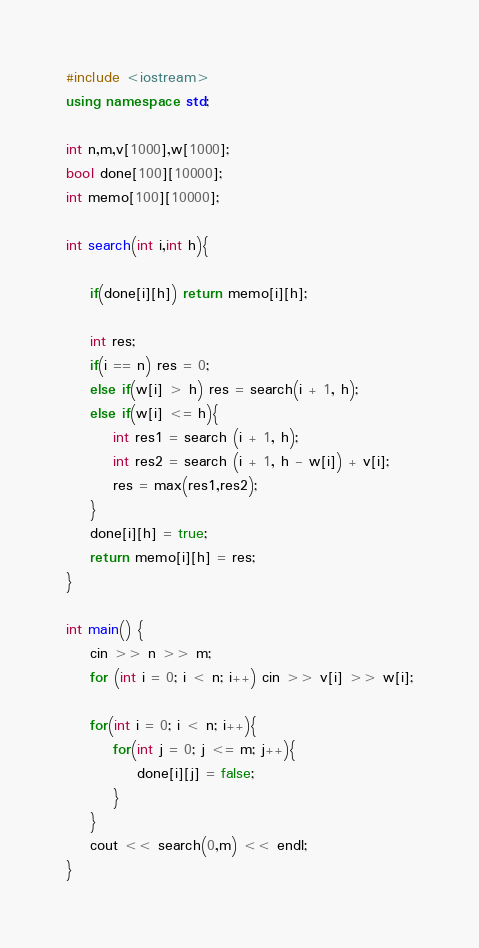Convert code to text. <code><loc_0><loc_0><loc_500><loc_500><_C++_>#include <iostream>
using namespace std;

int n,m,v[1000],w[1000];
bool done[100][10000];
int memo[100][10000];

int search(int i,int h){
	
	if(done[i][h]) return memo[i][h];
	
	int res;
	if(i == n) res = 0;
	else if(w[i] > h) res = search(i + 1, h);
	else if(w[i] <= h){
		int res1 = search (i + 1, h);
		int res2 = search (i + 1, h - w[i]) + v[i];
		res = max(res1,res2);
	}
	done[i][h] = true;
	return memo[i][h] = res;
}

int main() {
	cin >> n >> m;
	for (int i = 0; i < n; i++) cin >> v[i] >> w[i];
	
	for(int i = 0; i < n; i++){
		for(int j = 0; j <= m; j++){
			done[i][j] = false;
		}
	}
	cout << search(0,m) << endl;
}
</code> 